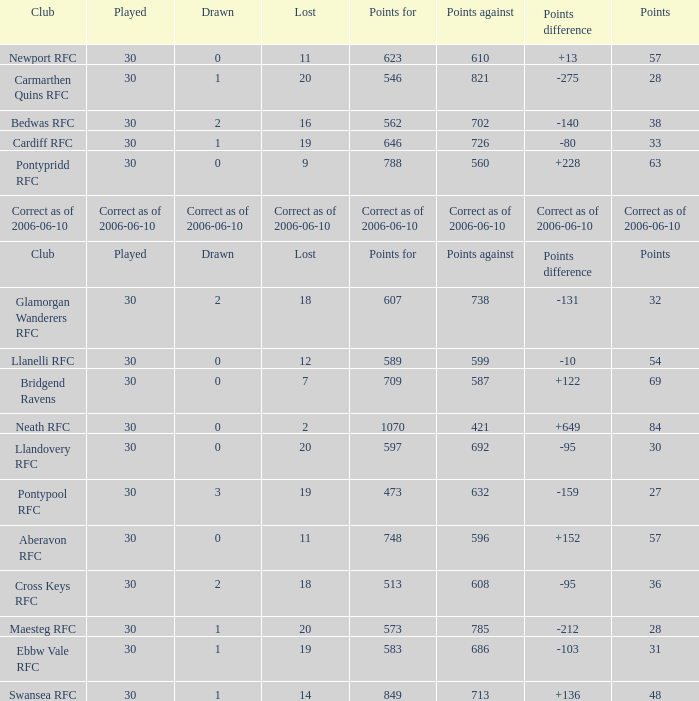What is Lost, when Drawn is "2", and when Points is "36"? 18.0. 